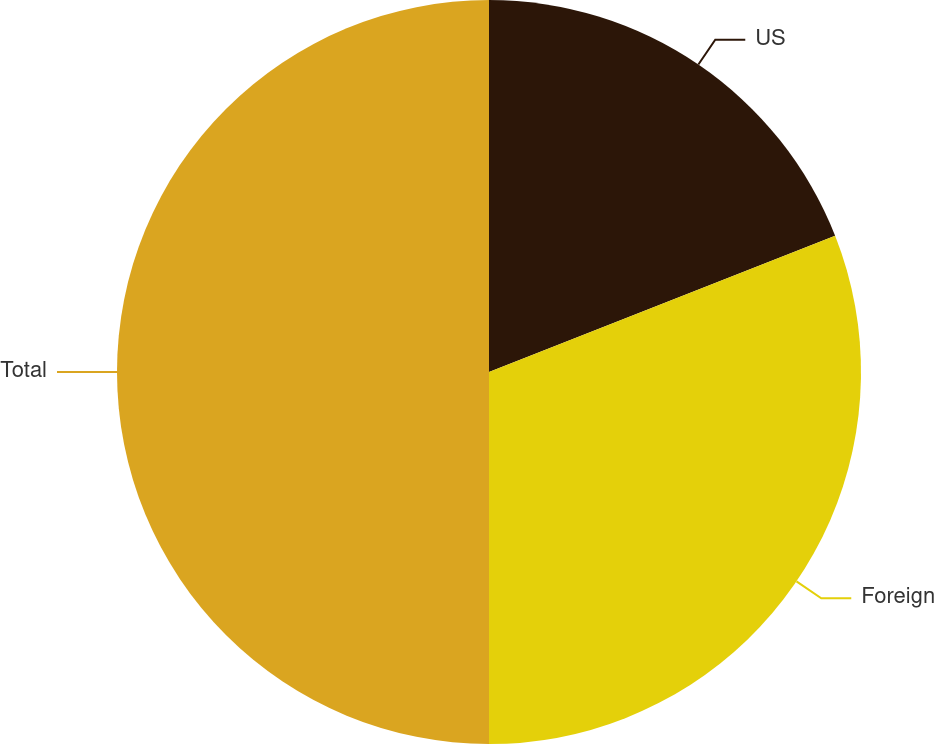<chart> <loc_0><loc_0><loc_500><loc_500><pie_chart><fcel>US<fcel>Foreign<fcel>Total<nl><fcel>19.03%<fcel>30.97%<fcel>50.0%<nl></chart> 